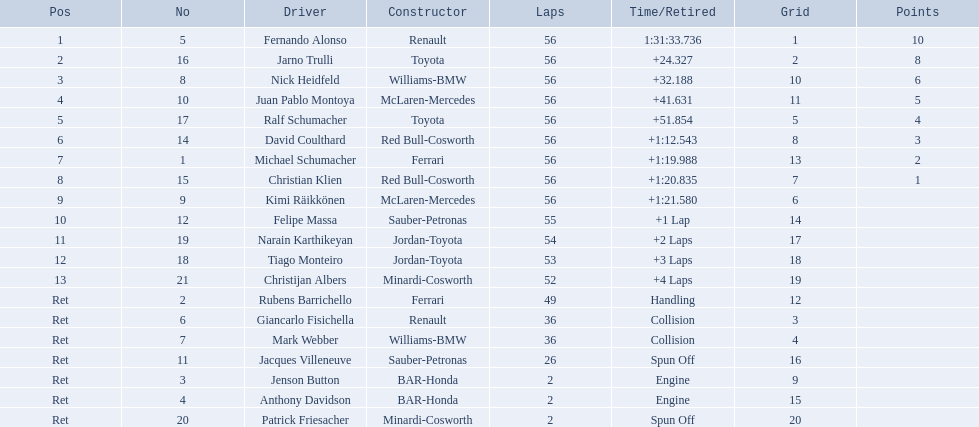Who was fernando alonso's teacher? Renault. How many circuits did fernando alonso complete? 56. How much time did it take alonso to finish the race? 1:31:33.736. 